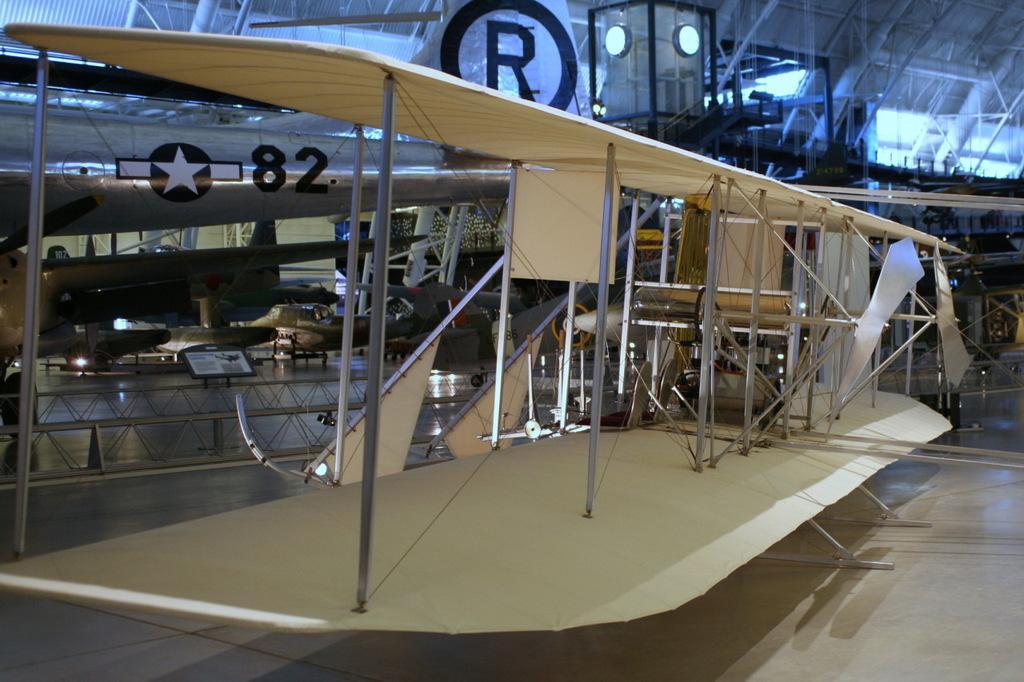Can you describe this image briefly? In this picture, it is looking like a stearman and behind the stearman there are some other things and a board on the path. 